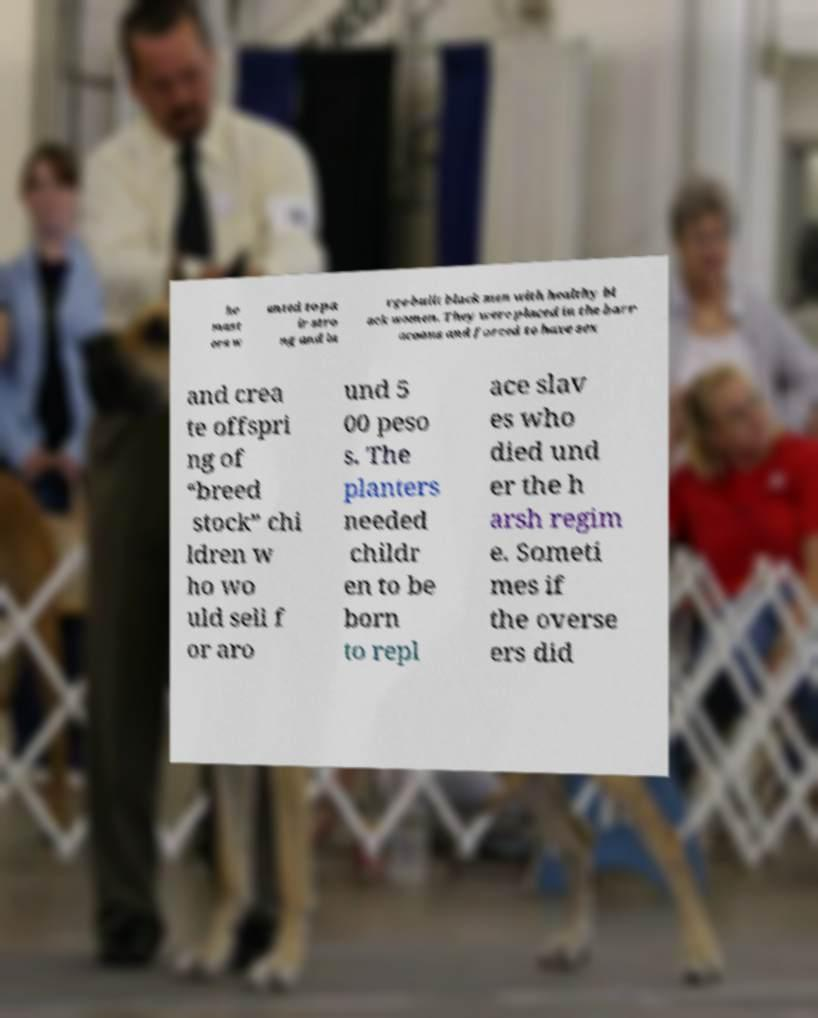What messages or text are displayed in this image? I need them in a readable, typed format. he mast ers w anted to pa ir stro ng and la rge-built black men with healthy bl ack women. They were placed in the barr acoons and forced to have sex and crea te offspri ng of “breed stock” chi ldren w ho wo uld sell f or aro und 5 00 peso s. The planters needed childr en to be born to repl ace slav es who died und er the h arsh regim e. Someti mes if the overse ers did 